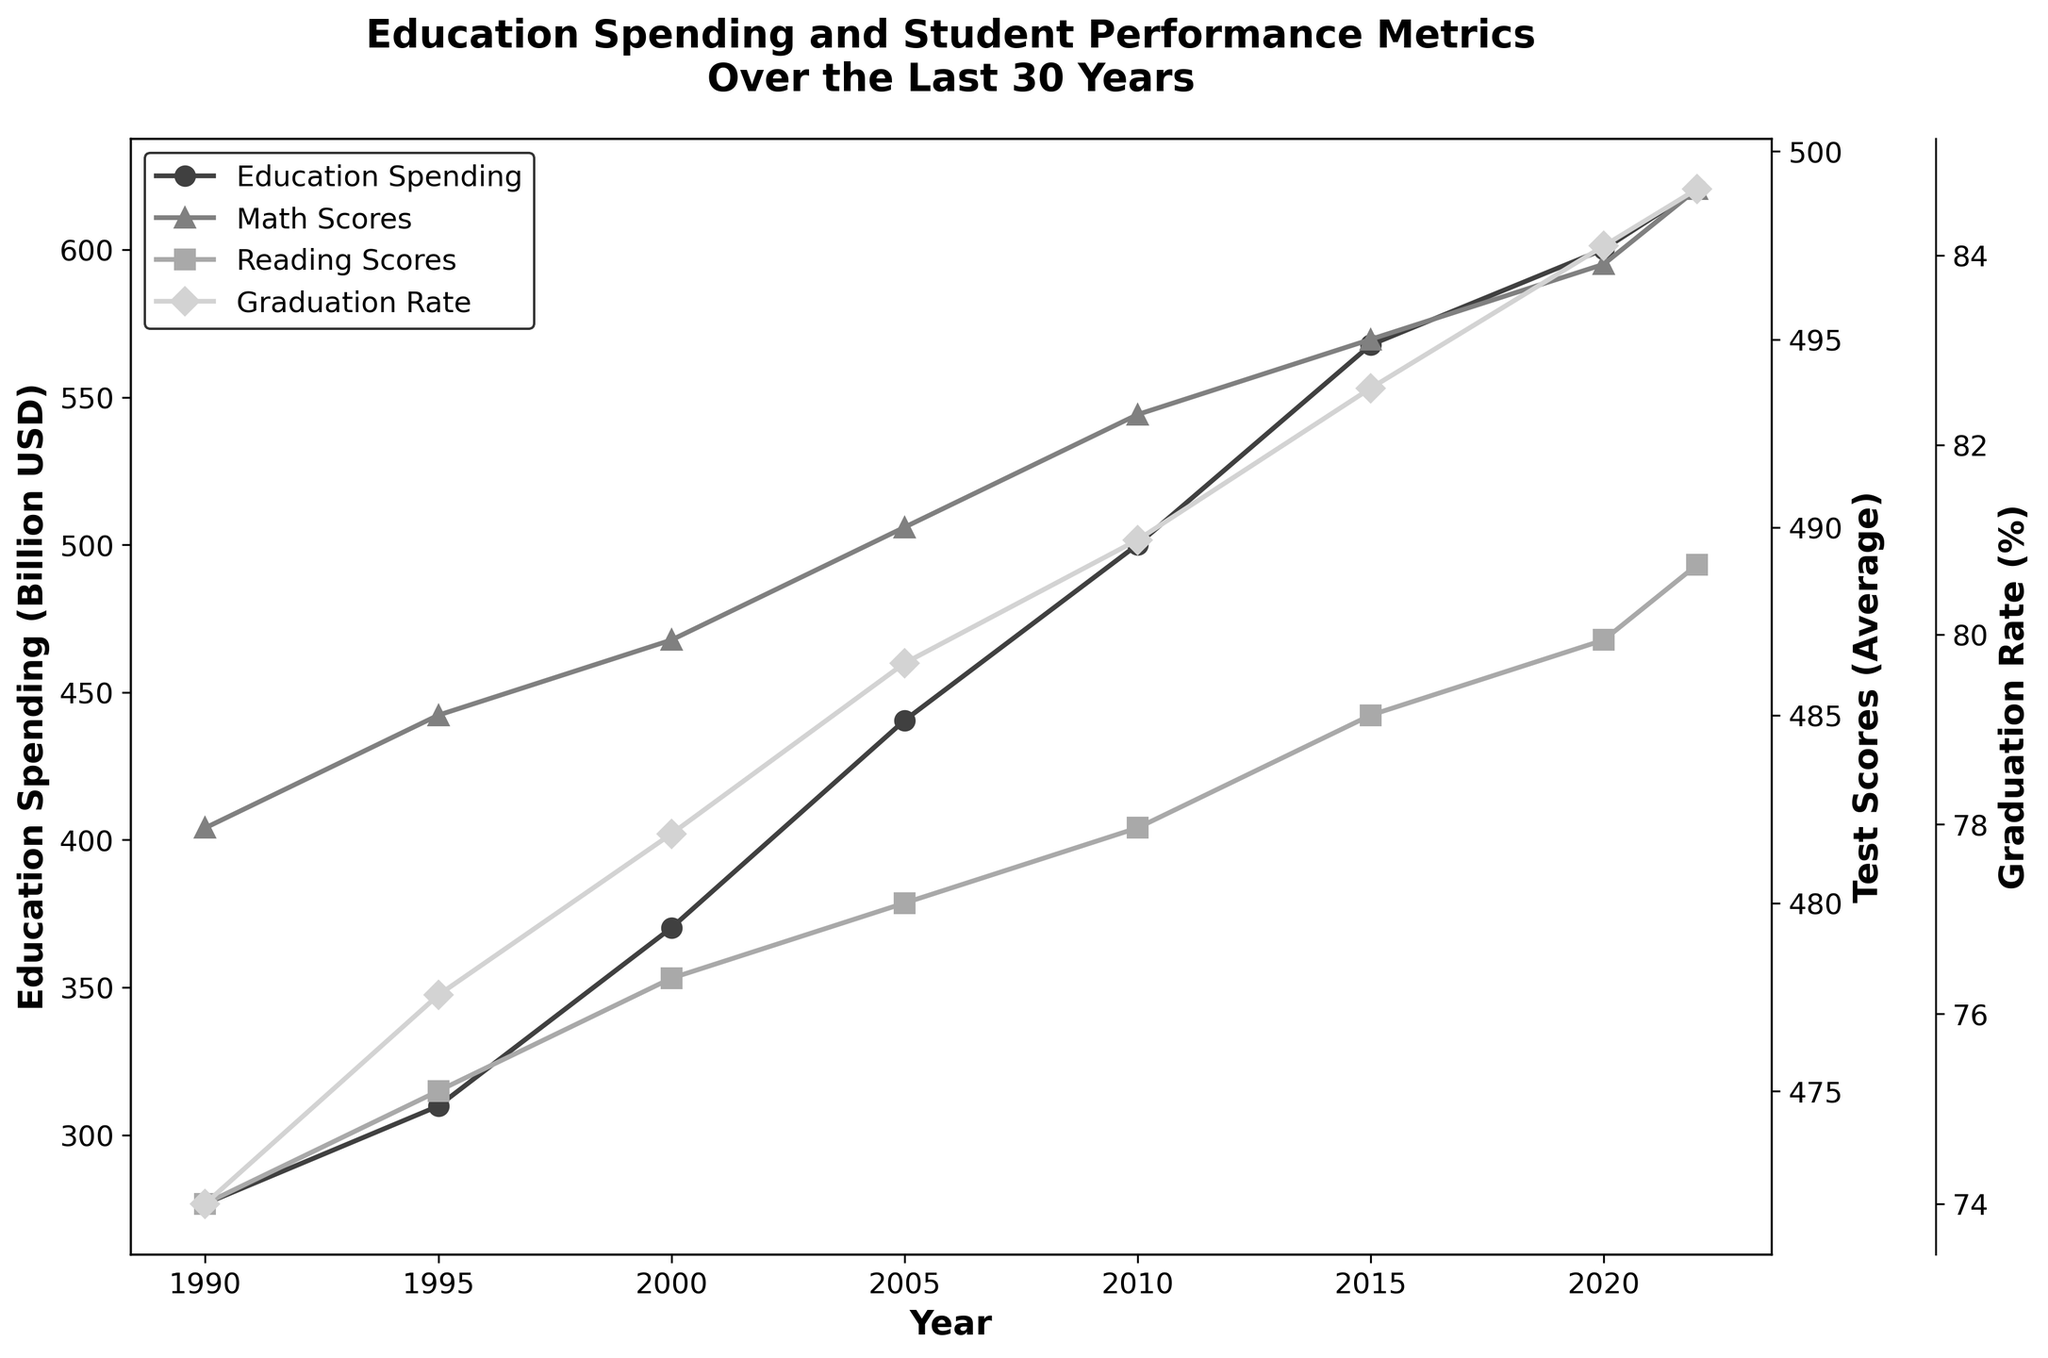What is the title of the figure? The title is displayed at the top of the figure and it summarizes what the plot is depicting.
Answer: Education Spending and Student Performance Metrics Over the Last 30 Years How many years are covered in the plot? Count the number of x-axis ticks, each representing a year.
Answer: 8 years Which year had the highest education spending? Look for the peak in the line representing Education Spending.
Answer: 2022 What was the average Math Score in 2000? Find the data point marked for Math Scores in the year 2000.
Answer: 487 Between which years did the graduation rate see the highest increase? Compare the Graduation Rate (%) line across years and identify which two consecutive years have the highest difference in value.
Answer: 2015 to 2020 By how much did Education Spending increase from 1990 to 2022? Subtract the Education Spending in 1990 from that in 2022. The values are 620.6 billion USD (2022) and 276.7 billion USD (1990).
Answer: 343.9 billion USD In what year did the average Reading Scores first reach 485? Look for the year when the Reading Scores' line first passes or hits 485.
Answer: 2015 What is the difference in Graduation Rate between 2010 and 2020? Subtract the Graduation Rate (%) in 2010 from that in 2020. The values are 84.1% (2020) and 81.0% (2010).
Answer: 3.1% How did average Math Scores change from 1990 to 2022? Compare the Math Scores in 1990 and 2022 and determine if they increased or decreased. The values are 482 (1990) and 499 (2022).
Answer: Increased by 17 points Which performance metric saw the least change over the 30 years? Visually compare the changes in the lines for Math Scores, Reading Scores, and Graduation Rate to identify the smallest variation.
Answer: Reading Scores 